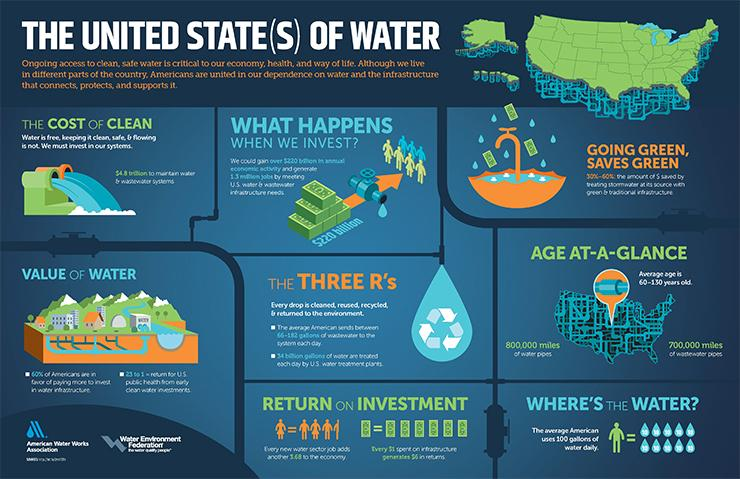Outline some significant characteristics in this image. The length of water pipes is approximately 800,000 miles. To expand the three R's, I will reuse, recycle, and return items whenever possible. 